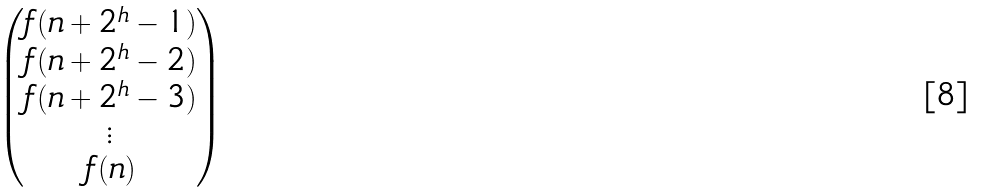<formula> <loc_0><loc_0><loc_500><loc_500>\begin{pmatrix} f ( n + 2 ^ { h } - 1 ) \\ f ( n + 2 ^ { h } - 2 ) \\ f ( n + 2 ^ { h } - 3 ) \\ \vdots \\ f ( n ) \\ \end{pmatrix}</formula> 